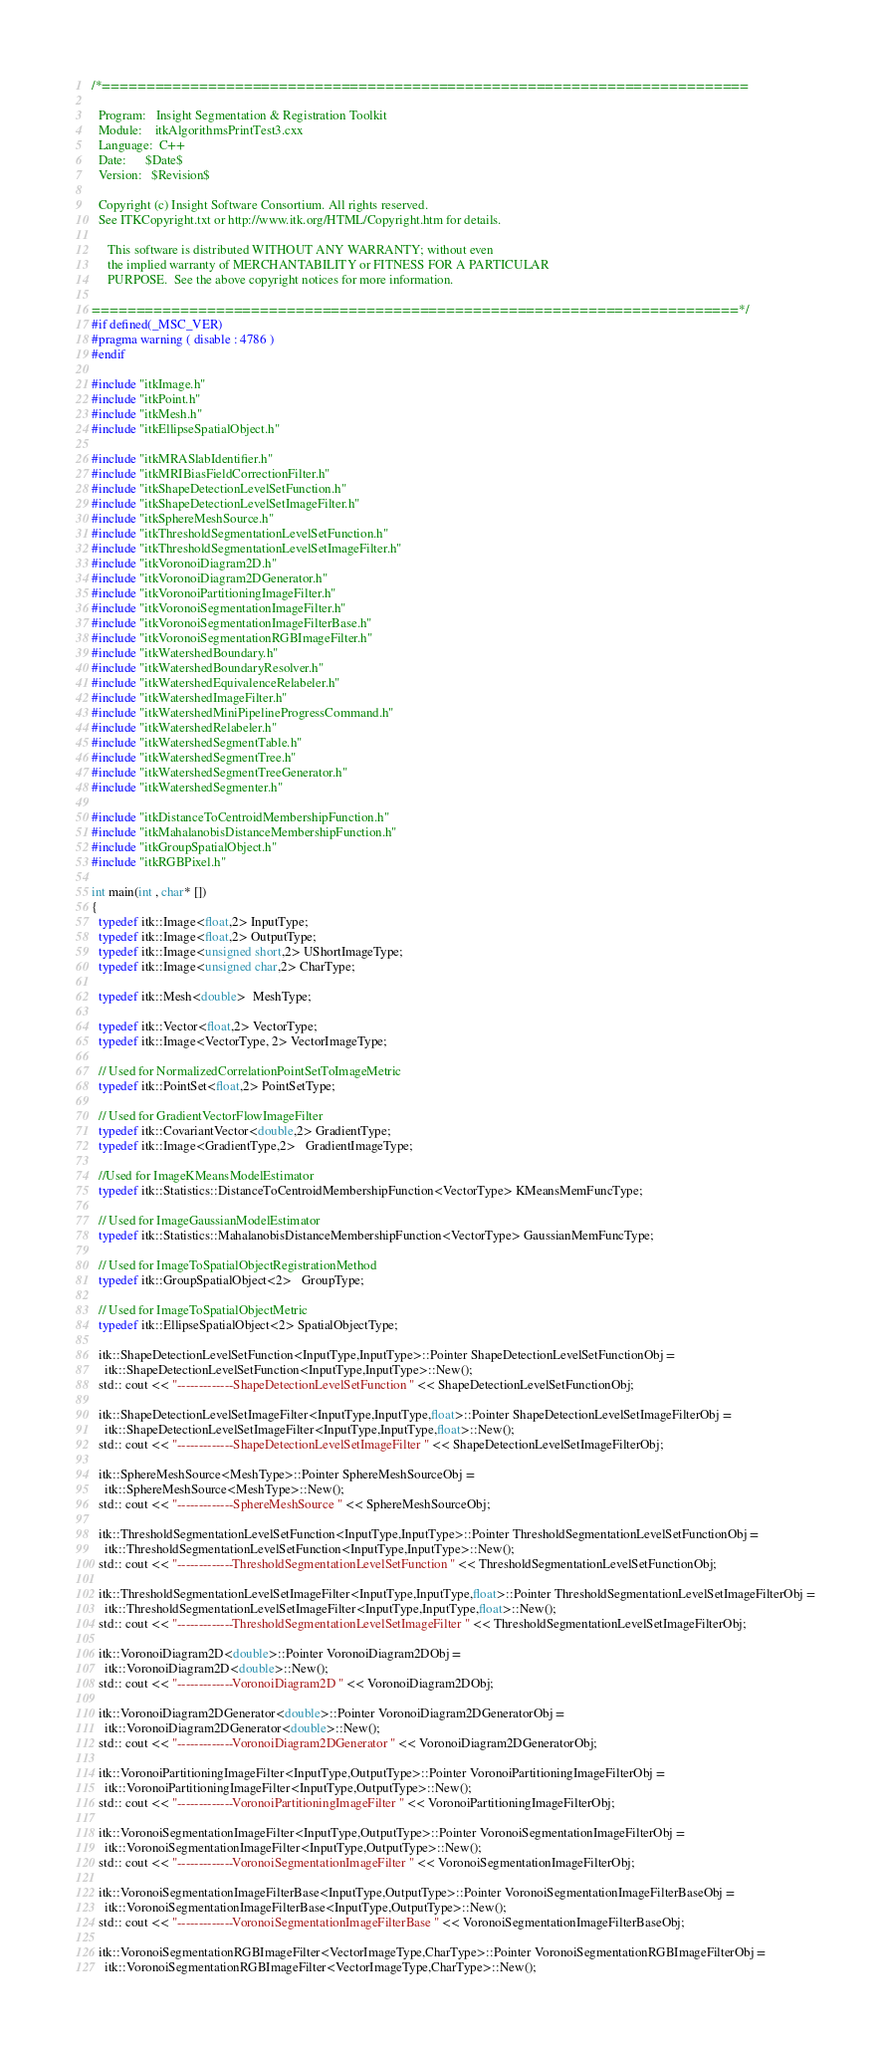Convert code to text. <code><loc_0><loc_0><loc_500><loc_500><_C++_>/*=========================================================================

  Program:   Insight Segmentation & Registration Toolkit
  Module:    itkAlgorithmsPrintTest3.cxx
  Language:  C++
  Date:      $Date$
  Version:   $Revision$

  Copyright (c) Insight Software Consortium. All rights reserved.
  See ITKCopyright.txt or http://www.itk.org/HTML/Copyright.htm for details.

     This software is distributed WITHOUT ANY WARRANTY; without even 
     the implied warranty of MERCHANTABILITY or FITNESS FOR A PARTICULAR 
     PURPOSE.  See the above copyright notices for more information.

=========================================================================*/
#if defined(_MSC_VER)
#pragma warning ( disable : 4786 )
#endif

#include "itkImage.h"
#include "itkPoint.h"
#include "itkMesh.h"
#include "itkEllipseSpatialObject.h"

#include "itkMRASlabIdentifier.h"
#include "itkMRIBiasFieldCorrectionFilter.h"
#include "itkShapeDetectionLevelSetFunction.h"
#include "itkShapeDetectionLevelSetImageFilter.h"
#include "itkSphereMeshSource.h"
#include "itkThresholdSegmentationLevelSetFunction.h"
#include "itkThresholdSegmentationLevelSetImageFilter.h"
#include "itkVoronoiDiagram2D.h"
#include "itkVoronoiDiagram2DGenerator.h"
#include "itkVoronoiPartitioningImageFilter.h"
#include "itkVoronoiSegmentationImageFilter.h"
#include "itkVoronoiSegmentationImageFilterBase.h"
#include "itkVoronoiSegmentationRGBImageFilter.h"
#include "itkWatershedBoundary.h"
#include "itkWatershedBoundaryResolver.h"
#include "itkWatershedEquivalenceRelabeler.h"
#include "itkWatershedImageFilter.h"
#include "itkWatershedMiniPipelineProgressCommand.h"
#include "itkWatershedRelabeler.h"
#include "itkWatershedSegmentTable.h"
#include "itkWatershedSegmentTree.h"
#include "itkWatershedSegmentTreeGenerator.h"
#include "itkWatershedSegmenter.h"

#include "itkDistanceToCentroidMembershipFunction.h"
#include "itkMahalanobisDistanceMembershipFunction.h"
#include "itkGroupSpatialObject.h"
#include "itkRGBPixel.h"

int main(int , char* [])
{
  typedef itk::Image<float,2> InputType; 
  typedef itk::Image<float,2> OutputType;
  typedef itk::Image<unsigned short,2> UShortImageType;
  typedef itk::Image<unsigned char,2> CharType;
  
  typedef itk::Mesh<double>  MeshType;
  
  typedef itk::Vector<float,2> VectorType;
  typedef itk::Image<VectorType, 2> VectorImageType;
  
  // Used for NormalizedCorrelationPointSetToImageMetric
  typedef itk::PointSet<float,2> PointSetType;
  
  // Used for GradientVectorFlowImageFilter
  typedef itk::CovariantVector<double,2> GradientType;
  typedef itk::Image<GradientType,2>   GradientImageType;

  //Used for ImageKMeansModelEstimator
  typedef itk::Statistics::DistanceToCentroidMembershipFunction<VectorType> KMeansMemFuncType;
  
  // Used for ImageGaussianModelEstimator
  typedef itk::Statistics::MahalanobisDistanceMembershipFunction<VectorType> GaussianMemFuncType;
  
  // Used for ImageToSpatialObjectRegistrationMethod
  typedef itk::GroupSpatialObject<2>   GroupType;

  // Used for ImageToSpatialObjectMetric
  typedef itk::EllipseSpatialObject<2> SpatialObjectType;

  itk::ShapeDetectionLevelSetFunction<InputType,InputType>::Pointer ShapeDetectionLevelSetFunctionObj =
    itk::ShapeDetectionLevelSetFunction<InputType,InputType>::New();
  std:: cout << "-------------ShapeDetectionLevelSetFunction " << ShapeDetectionLevelSetFunctionObj;

  itk::ShapeDetectionLevelSetImageFilter<InputType,InputType,float>::Pointer ShapeDetectionLevelSetImageFilterObj =
    itk::ShapeDetectionLevelSetImageFilter<InputType,InputType,float>::New();
  std:: cout << "-------------ShapeDetectionLevelSetImageFilter " << ShapeDetectionLevelSetImageFilterObj;

  itk::SphereMeshSource<MeshType>::Pointer SphereMeshSourceObj =
    itk::SphereMeshSource<MeshType>::New();
  std:: cout << "-------------SphereMeshSource " << SphereMeshSourceObj;

  itk::ThresholdSegmentationLevelSetFunction<InputType,InputType>::Pointer ThresholdSegmentationLevelSetFunctionObj =
    itk::ThresholdSegmentationLevelSetFunction<InputType,InputType>::New();
  std:: cout << "-------------ThresholdSegmentationLevelSetFunction " << ThresholdSegmentationLevelSetFunctionObj;

  itk::ThresholdSegmentationLevelSetImageFilter<InputType,InputType,float>::Pointer ThresholdSegmentationLevelSetImageFilterObj =
    itk::ThresholdSegmentationLevelSetImageFilter<InputType,InputType,float>::New();
  std:: cout << "-------------ThresholdSegmentationLevelSetImageFilter " << ThresholdSegmentationLevelSetImageFilterObj;

  itk::VoronoiDiagram2D<double>::Pointer VoronoiDiagram2DObj =
    itk::VoronoiDiagram2D<double>::New();
  std:: cout << "-------------VoronoiDiagram2D " << VoronoiDiagram2DObj;

  itk::VoronoiDiagram2DGenerator<double>::Pointer VoronoiDiagram2DGeneratorObj =
    itk::VoronoiDiagram2DGenerator<double>::New();
  std:: cout << "-------------VoronoiDiagram2DGenerator " << VoronoiDiagram2DGeneratorObj;

  itk::VoronoiPartitioningImageFilter<InputType,OutputType>::Pointer VoronoiPartitioningImageFilterObj =
    itk::VoronoiPartitioningImageFilter<InputType,OutputType>::New();
  std:: cout << "-------------VoronoiPartitioningImageFilter " << VoronoiPartitioningImageFilterObj;

  itk::VoronoiSegmentationImageFilter<InputType,OutputType>::Pointer VoronoiSegmentationImageFilterObj =
    itk::VoronoiSegmentationImageFilter<InputType,OutputType>::New();
  std:: cout << "-------------VoronoiSegmentationImageFilter " << VoronoiSegmentationImageFilterObj;

  itk::VoronoiSegmentationImageFilterBase<InputType,OutputType>::Pointer VoronoiSegmentationImageFilterBaseObj =
    itk::VoronoiSegmentationImageFilterBase<InputType,OutputType>::New();
  std:: cout << "-------------VoronoiSegmentationImageFilterBase " << VoronoiSegmentationImageFilterBaseObj;

  itk::VoronoiSegmentationRGBImageFilter<VectorImageType,CharType>::Pointer VoronoiSegmentationRGBImageFilterObj =
    itk::VoronoiSegmentationRGBImageFilter<VectorImageType,CharType>::New();</code> 